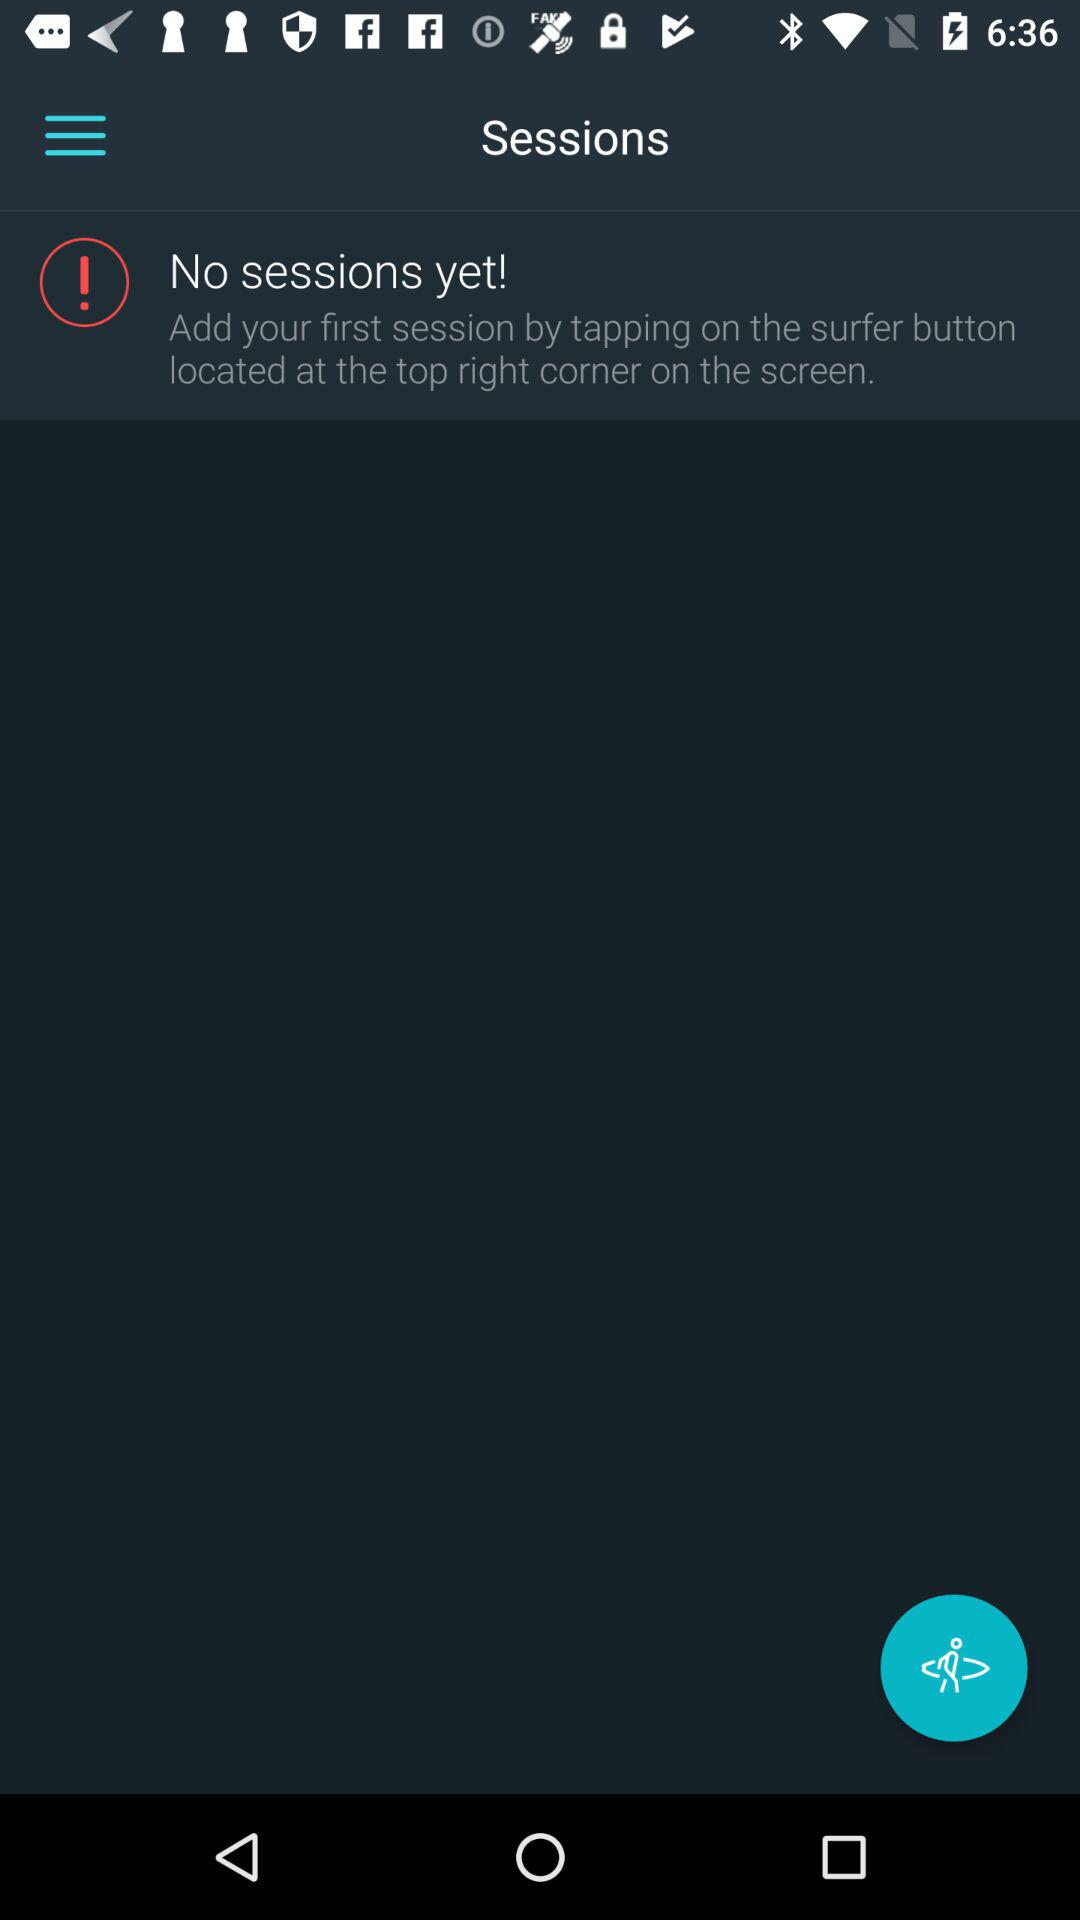Is there any session? There is no session. 